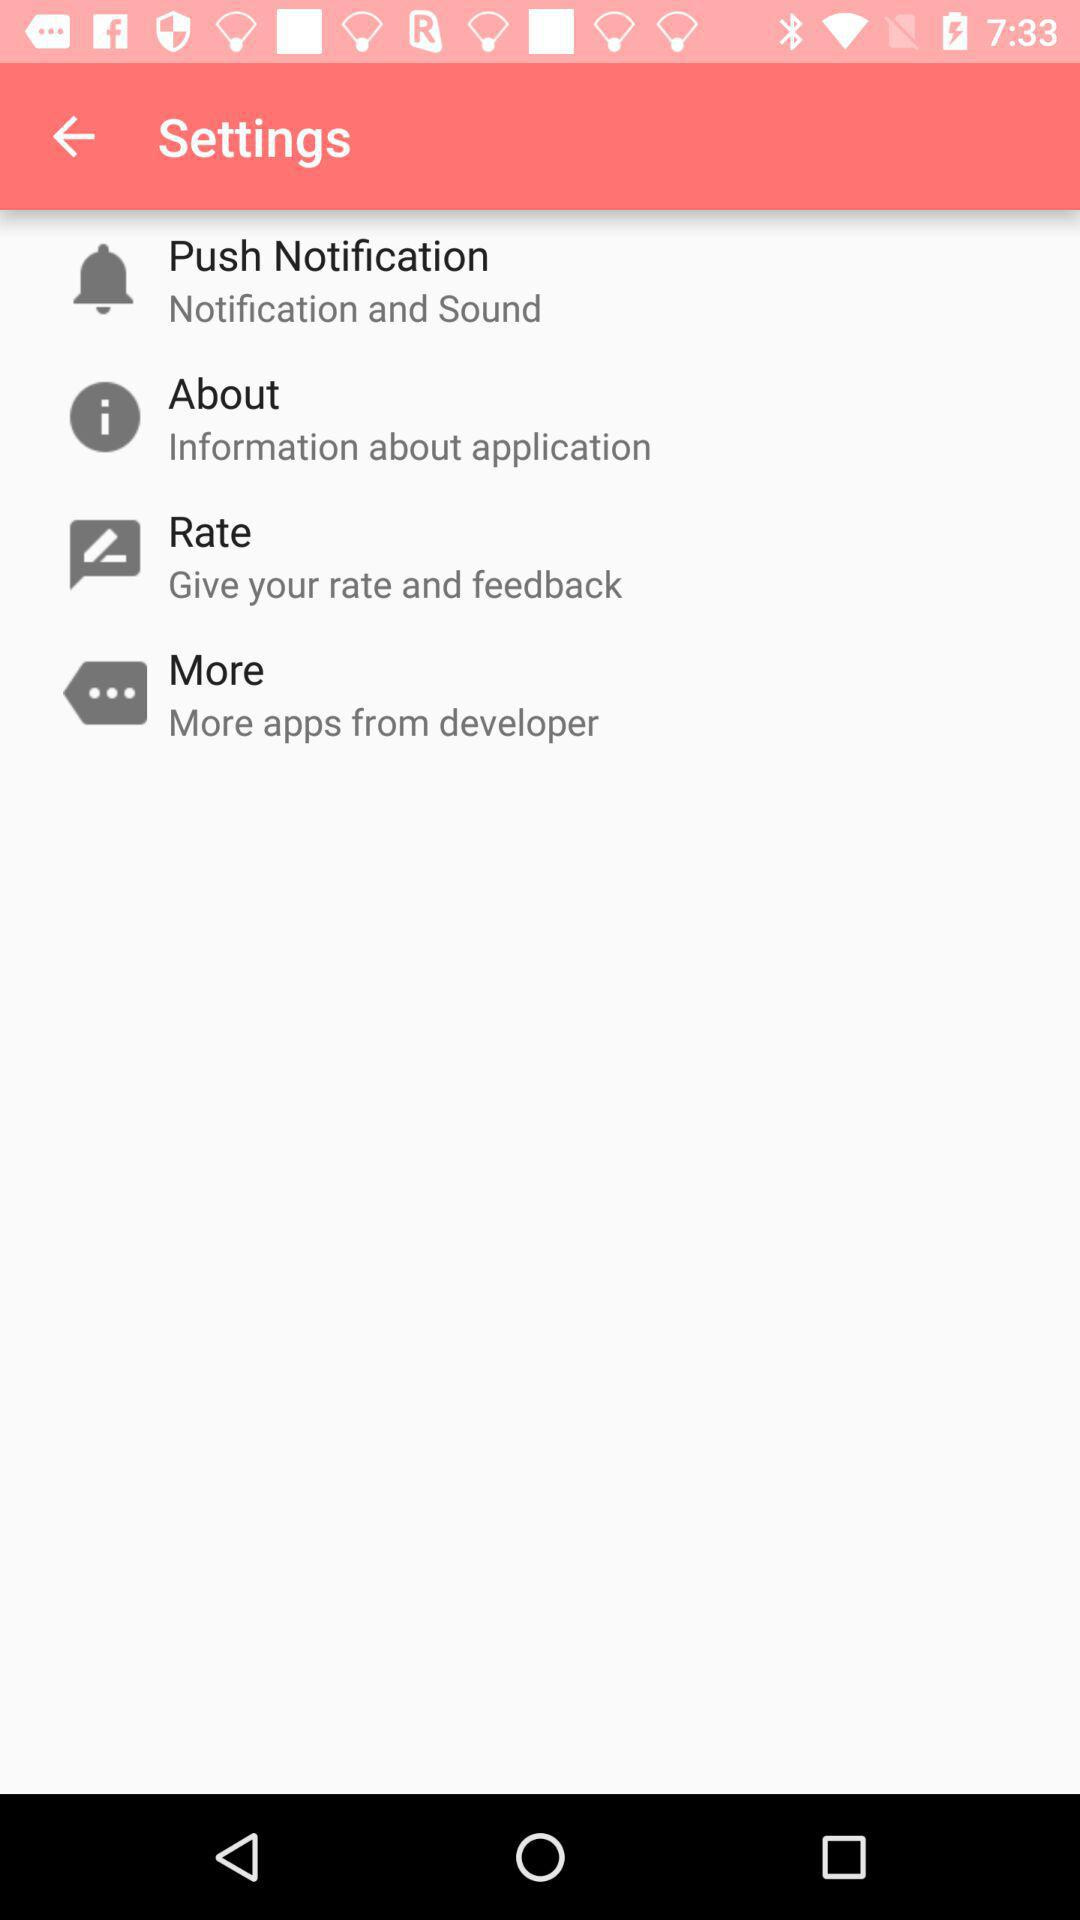How many items are there in the settings menu?
Answer the question using a single word or phrase. 4 